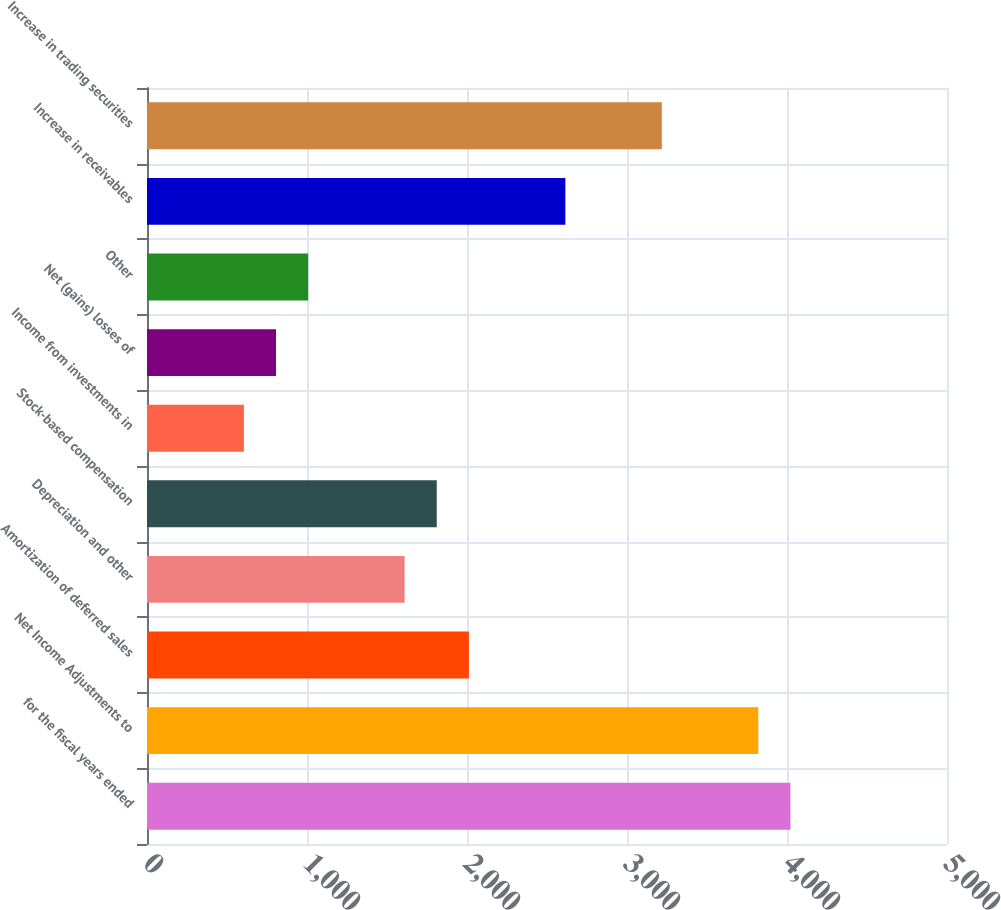Convert chart to OTSL. <chart><loc_0><loc_0><loc_500><loc_500><bar_chart><fcel>for the fiscal years ended<fcel>Net Income Adjustments to<fcel>Amortization of deferred sales<fcel>Depreciation and other<fcel>Stock-based compensation<fcel>Income from investments in<fcel>Net (gains) losses of<fcel>Other<fcel>Increase in receivables<fcel>Increase in trading securities<nl><fcel>4021.5<fcel>3820.55<fcel>2012<fcel>1610.1<fcel>1811.05<fcel>605.35<fcel>806.3<fcel>1007.25<fcel>2614.85<fcel>3217.7<nl></chart> 